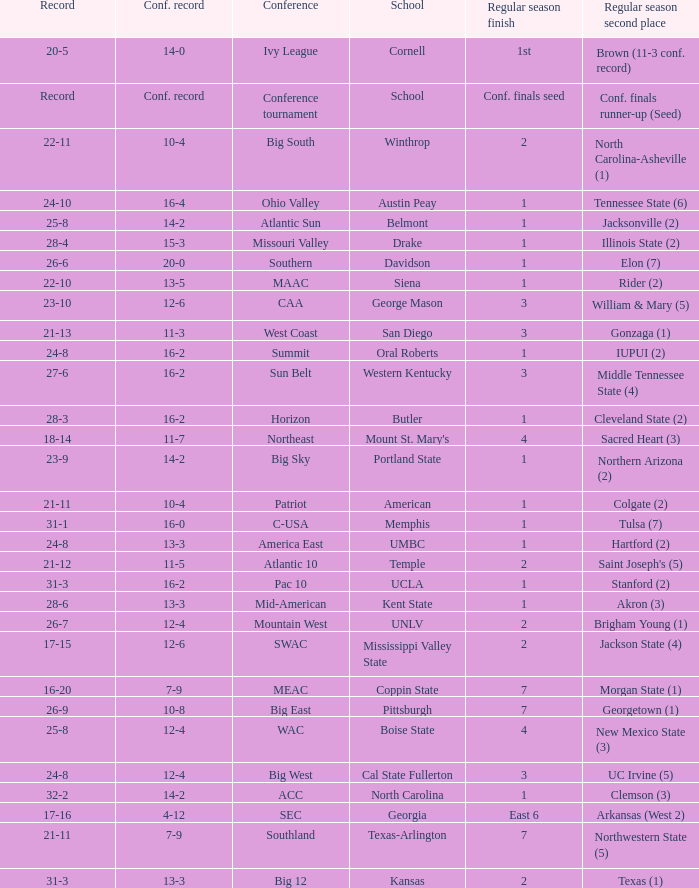Which qualifying schools were in the Patriot conference? American. 